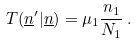Convert formula to latex. <formula><loc_0><loc_0><loc_500><loc_500>T ( \underline { n } ^ { \prime } | \underline { n } ) = \mu _ { 1 } \frac { n _ { 1 } } { N _ { 1 } } \, .</formula> 